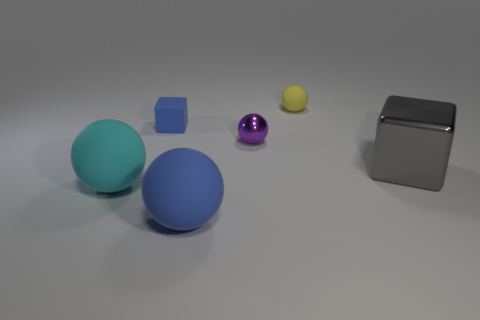Subtract all shiny spheres. How many spheres are left? 3 Add 4 purple spheres. How many objects exist? 10 Subtract all spheres. How many objects are left? 2 Subtract all green blocks. How many green balls are left? 0 Subtract all blue metallic cubes. Subtract all purple things. How many objects are left? 5 Add 2 tiny cubes. How many tiny cubes are left? 3 Add 2 blocks. How many blocks exist? 4 Subtract all purple balls. How many balls are left? 3 Subtract 1 blue cubes. How many objects are left? 5 Subtract 2 spheres. How many spheres are left? 2 